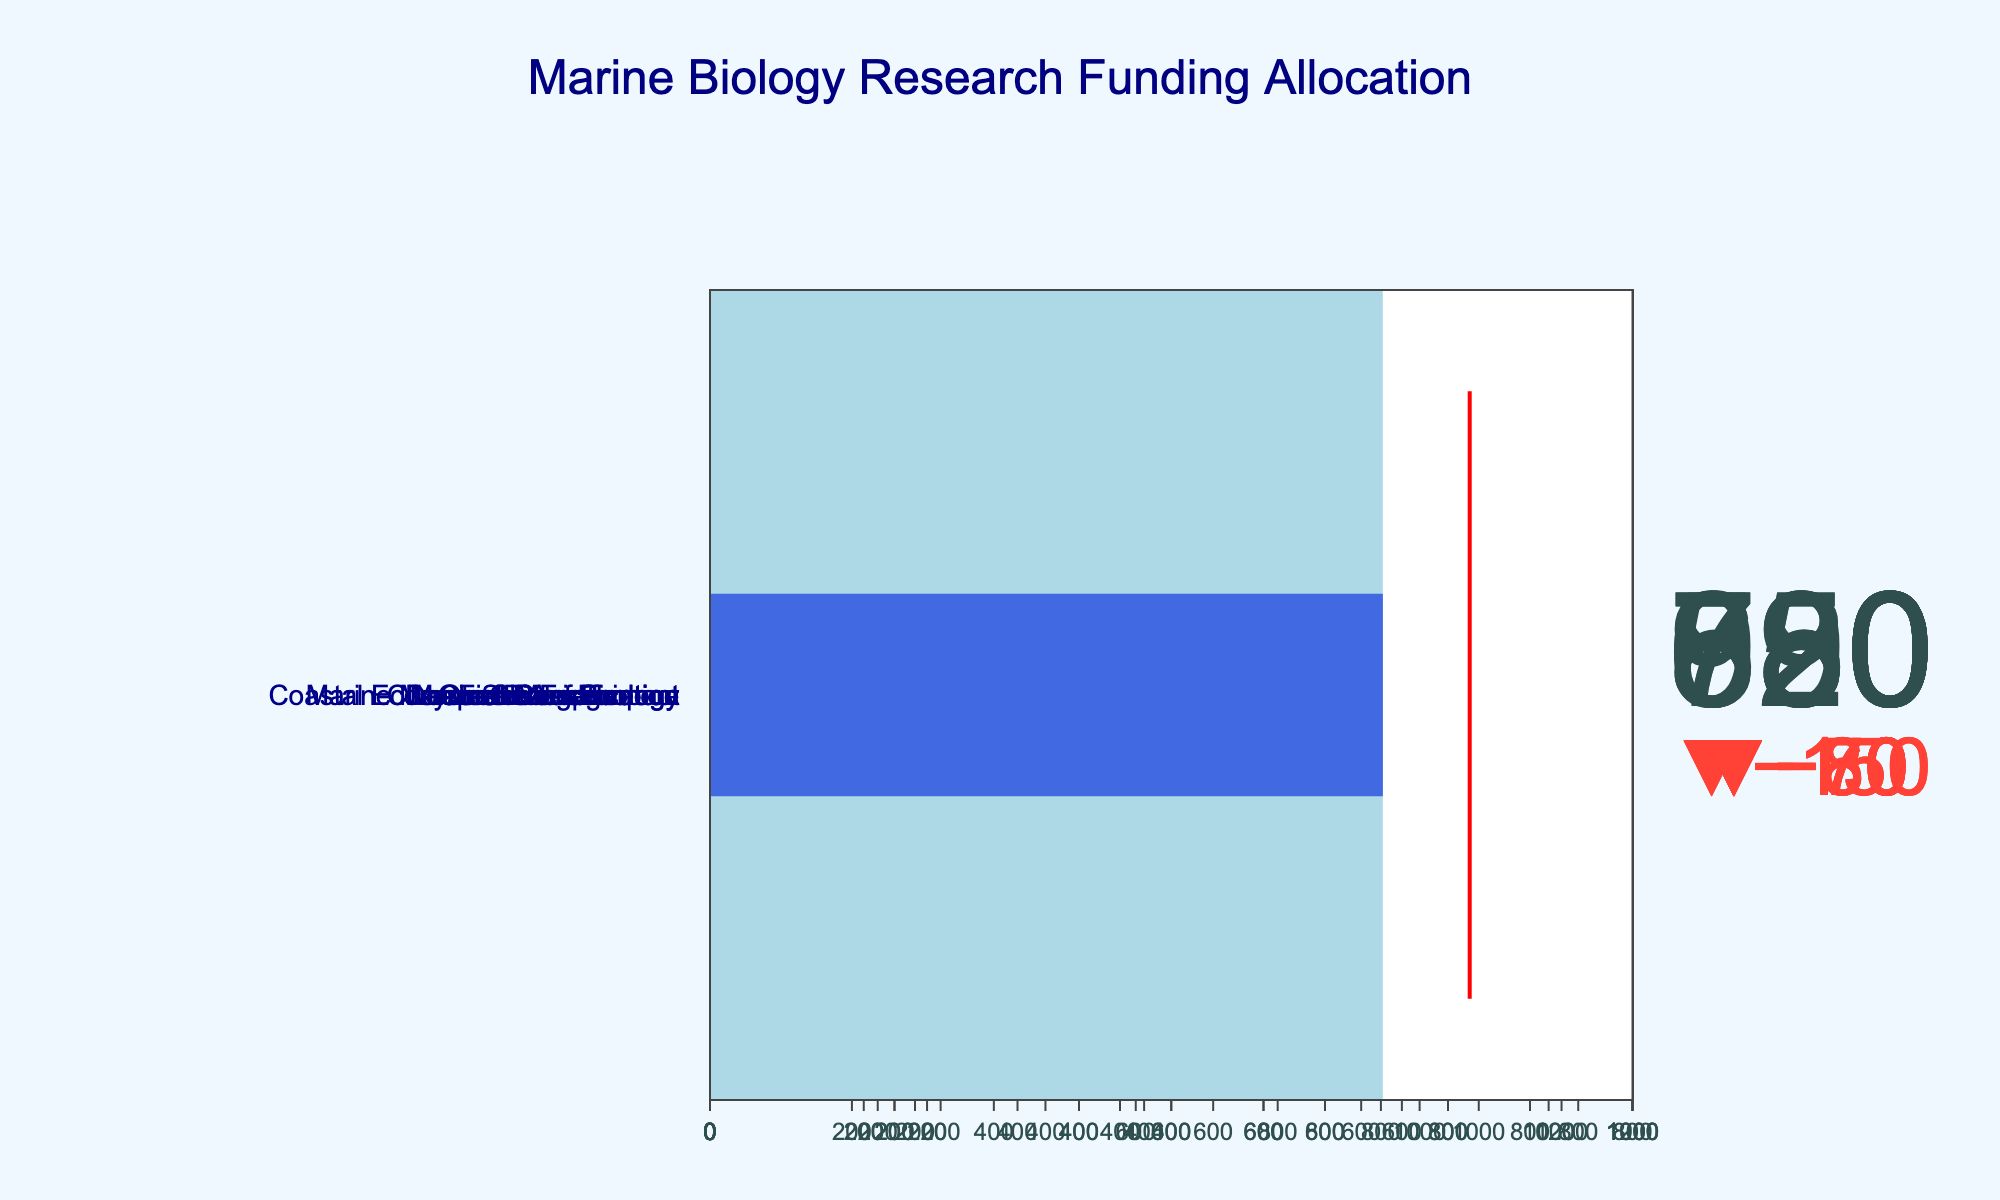What is the title of the figure? The title is usually displayed prominently at the top of the figure. In this case, it is "Marine Biology Research Funding Allocation".
Answer: Marine Biology Research Funding Allocation Which research area received the highest actual funding? Look for the bullet chart with the longest blue bar. The longest blue bar is for Deep-Sea Exploration, with an actual funding of $950K.
Answer: Deep-Sea Exploration What is the target funding amount for Marine Mammal Conservation? Each bullet chart has a red line indicating the target funding. For Marine Mammal Conservation, the red line indicates the target funding of $750K.
Answer: $750K By how much did the actual funding exceed the target funding for Climate Change Impact? Observe the Climate Change Impact bullet chart. The actual funding ($880K) is compared to the target funding ($950K). Calculate $950K - $880K.
Answer: $70K short Which research area had actual funding closest to its target funding? Identify the bullet chart where the actual funding (blue bar) is closest to the red line (target). Coral Reef Ecology had $720K actual funding and $800K target, showing minimal deviation.
Answer: Coral Reef Ecology What is the difference in maximum funding between Ocean Acidification and Coral Reef Ecology? Look at the gray bar lengths for each. Ocean Acidification's maximum funding is $1200K and Coral Reef Ecology's is $1000K. Calculate $1200K - $1000K.
Answer: $200K What is the total actual funding for Ocean Acidification and Deep-Sea Exploration? Add the actual funding amounts for both areas: $850K (Ocean Acidification) + $950K (Deep-Sea Exploration).
Answer: $1,800K Which research area received the lowest actual funding relative to its maximum funding? Determine the percentage of actual funding to maximum funding for all areas and identify the smallest percentage. Coastal Ecosystem Management had $580K actual and $800K maximum, resulting in 72.5%.
Answer: Coastal Ecosystem Management How much more maximum funding does Fisheries Science have compared to Marine Biotechnology? Compare the maximum funding; Fisheries Science's is $1000K and Marine Biotechnology's is $850K. Calculate $1000K - $850K.
Answer: $150K If the total target funding for all areas was a fixed budget, how much funding was unmet across all areas combined? Calculate the difference for each area where actual funding is less than target funding and sum those differences: (1000-850) + (800-720) + (750-680) + (1100-950) + (650-580) + (850-790) + (950-880) + (700-620).
Answer: $710K 